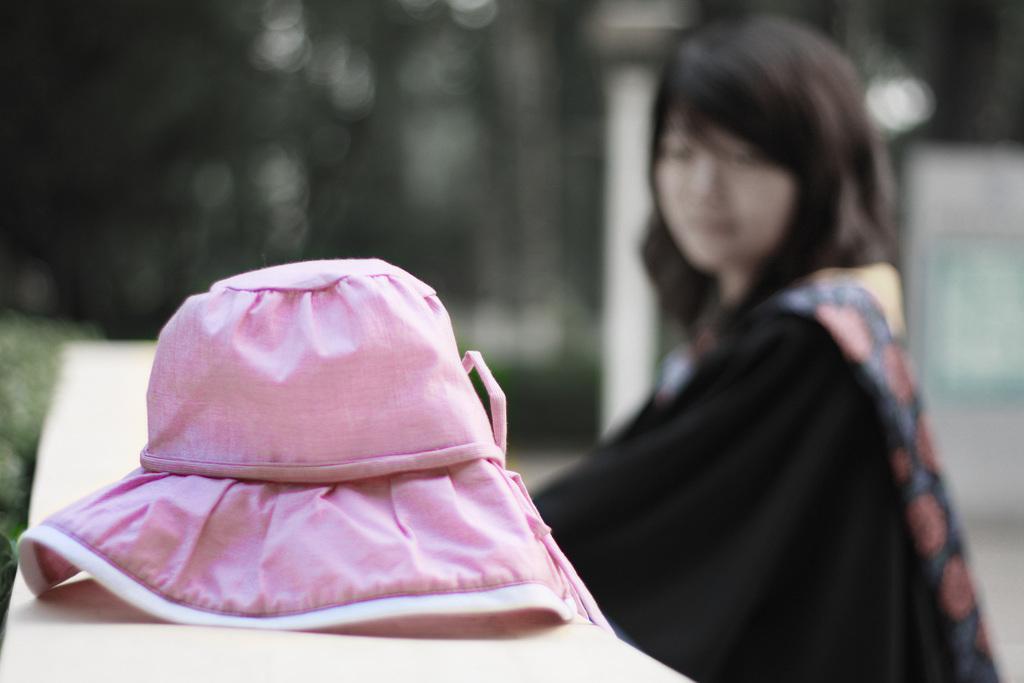Please provide a concise description of this image. In this image I can see a cap which is in pink color. Background I can see a person sitting and trees in green color. 